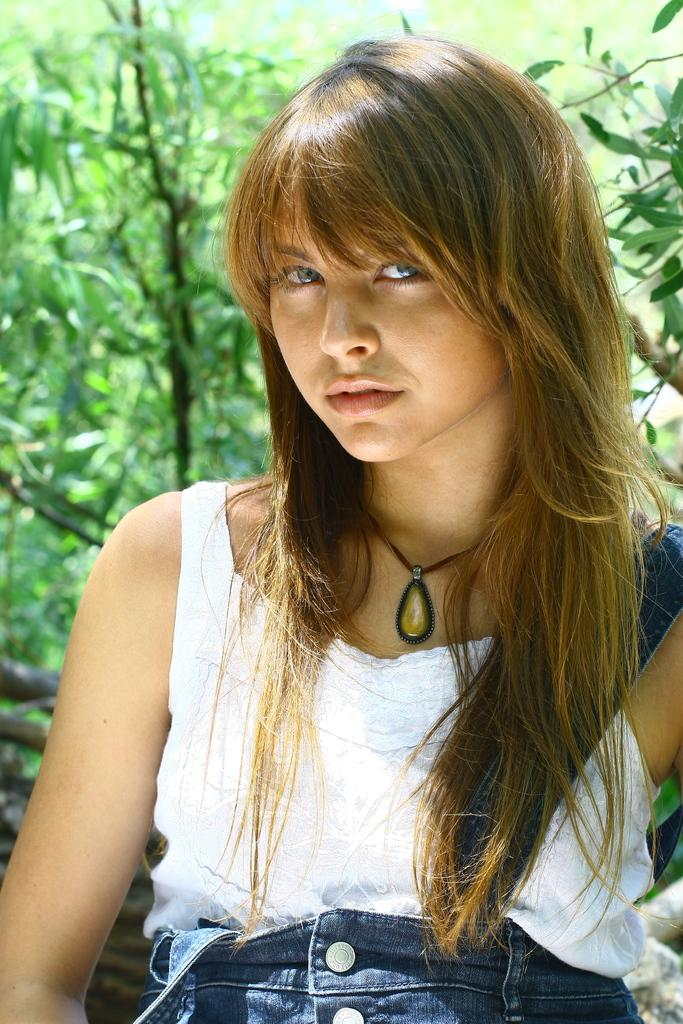Who is present in the image? There is a woman in the image. What is the woman doing in the image? The woman is standing in the image. What is the woman's facial expression in the image? The woman is smiling in the image. What is the woman wearing in the image? The woman is wearing a dress and a necklace in the image. What can be seen in the background of the image? There are trees in the background of the image. What is the color of the trees in the image? The trees are green in color in the image. What type of quilt is draped over the woman's shoulder in the image? There is no quilt present in the image; the woman is wearing a dress and a necklace. Can you tell me how many cups are visible on the table in the image? There is no table or cups present in the image; it features a woman standing with trees in the background. 